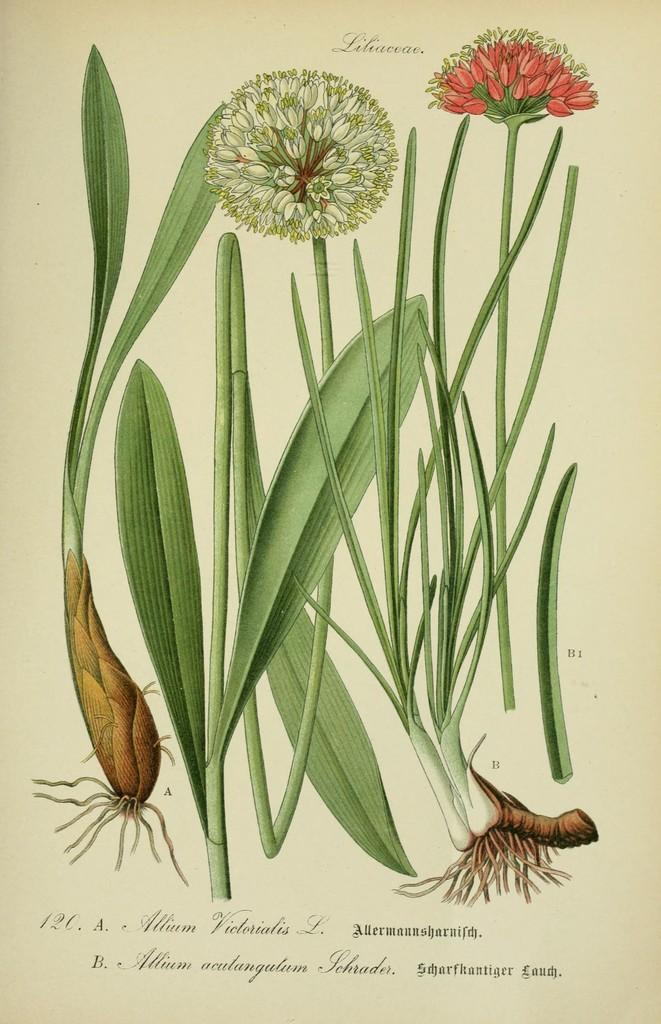What type of images are present in the picture? The image contains pictures of plants and flowers on paper. Can you describe any additional elements in the image? There is text at the bottom of the image. Is there a person holding the plant in the image? There is no person present in the image; it only contains pictures of plants and flowers on paper and text at the bottom. Can you tell me how many drawers are visible in the image? There are no drawers present in the image. 